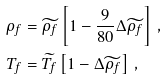Convert formula to latex. <formula><loc_0><loc_0><loc_500><loc_500>\rho _ { f } & = \widetilde { \rho _ { f } } \left [ 1 - \frac { 9 } { 8 0 } \Delta \widetilde { \rho _ { f } } \right ] \, , \\ T _ { f } & = \widetilde { T _ { f } } \left [ 1 - \Delta \widetilde { \rho _ { f } } \right ] \, ,</formula> 